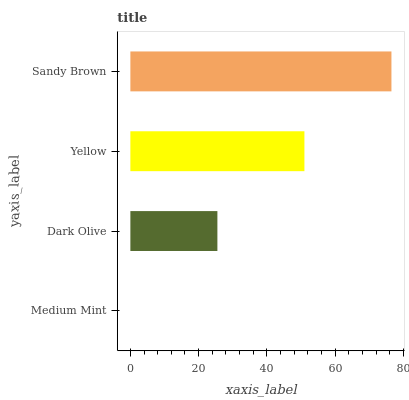Is Medium Mint the minimum?
Answer yes or no. Yes. Is Sandy Brown the maximum?
Answer yes or no. Yes. Is Dark Olive the minimum?
Answer yes or no. No. Is Dark Olive the maximum?
Answer yes or no. No. Is Dark Olive greater than Medium Mint?
Answer yes or no. Yes. Is Medium Mint less than Dark Olive?
Answer yes or no. Yes. Is Medium Mint greater than Dark Olive?
Answer yes or no. No. Is Dark Olive less than Medium Mint?
Answer yes or no. No. Is Yellow the high median?
Answer yes or no. Yes. Is Dark Olive the low median?
Answer yes or no. Yes. Is Sandy Brown the high median?
Answer yes or no. No. Is Yellow the low median?
Answer yes or no. No. 